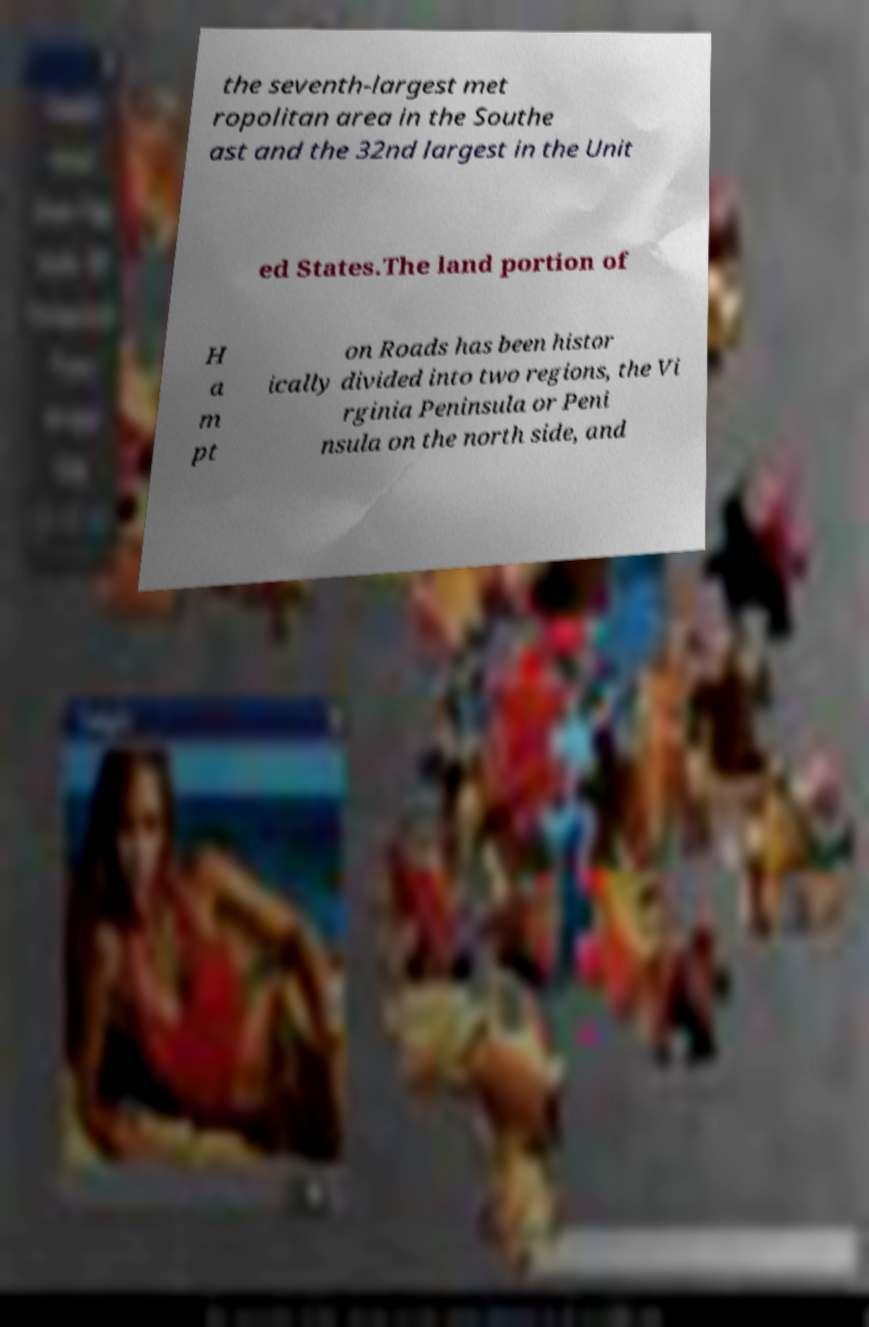Please identify and transcribe the text found in this image. the seventh-largest met ropolitan area in the Southe ast and the 32nd largest in the Unit ed States.The land portion of H a m pt on Roads has been histor ically divided into two regions, the Vi rginia Peninsula or Peni nsula on the north side, and 